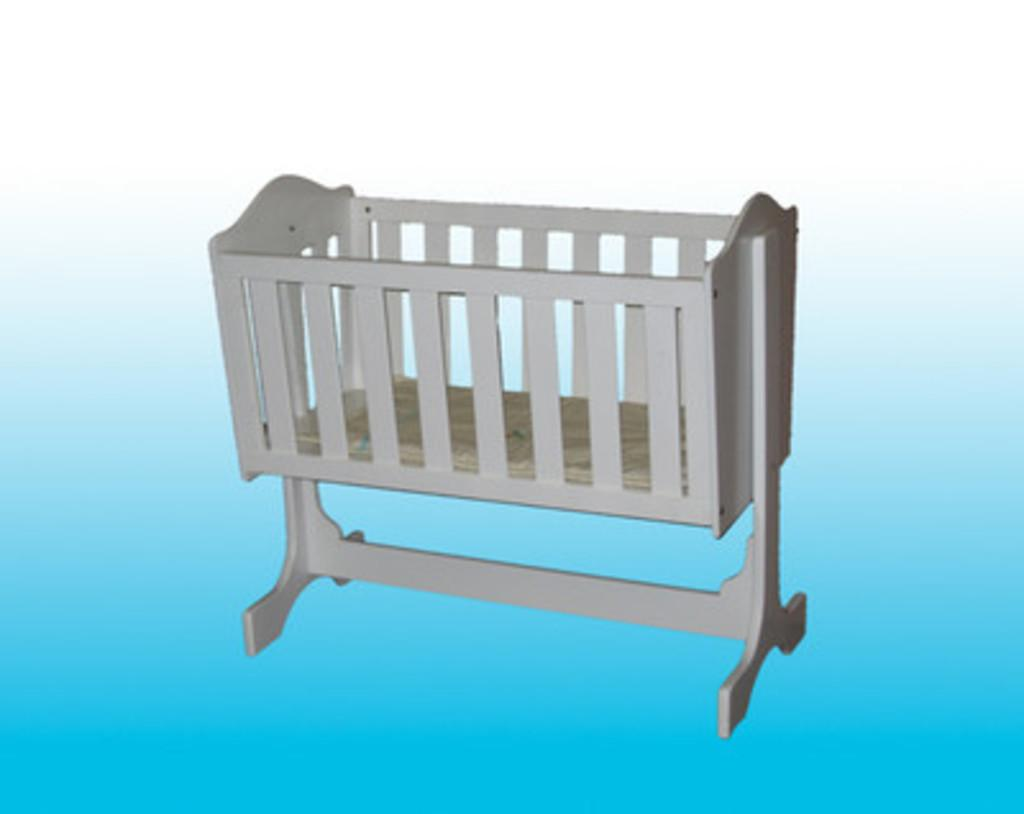What type of furniture or object is present in the image? There is a cradle in the image. What type of pancake is being served in the cradle in the image? There is no pancake present in the image, as it only features a cradle. 